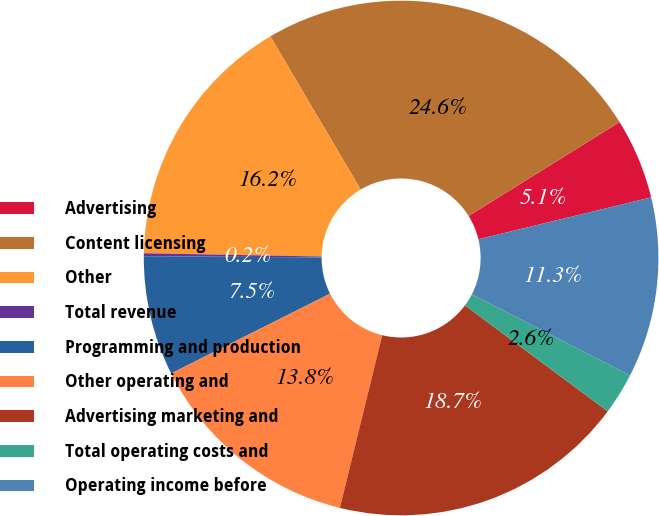Convert chart to OTSL. <chart><loc_0><loc_0><loc_500><loc_500><pie_chart><fcel>Advertising<fcel>Content licensing<fcel>Other<fcel>Total revenue<fcel>Programming and production<fcel>Other operating and<fcel>Advertising marketing and<fcel>Total operating costs and<fcel>Operating income before<nl><fcel>5.07%<fcel>24.63%<fcel>16.22%<fcel>0.18%<fcel>7.52%<fcel>13.77%<fcel>18.66%<fcel>2.62%<fcel>11.33%<nl></chart> 